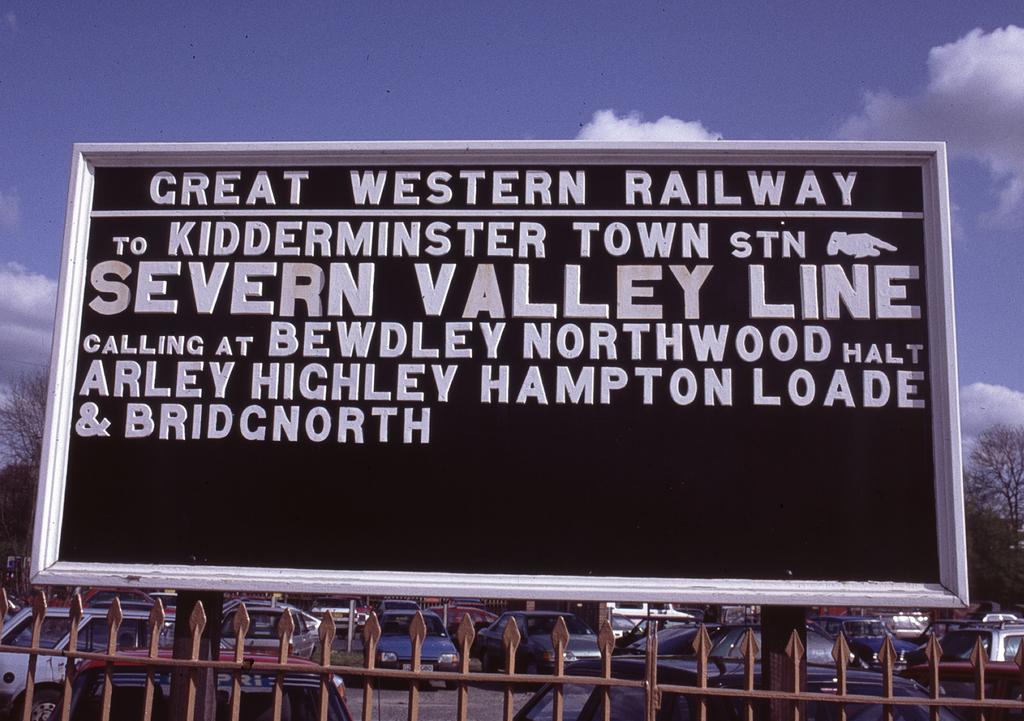What hemisphere is this railway located at?
Your response must be concise. Western. What line is that?
Your answer should be compact. Severn valley. 